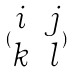Convert formula to latex. <formula><loc_0><loc_0><loc_500><loc_500>( \begin{matrix} i & j \\ k & l \end{matrix} )</formula> 